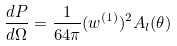<formula> <loc_0><loc_0><loc_500><loc_500>\frac { d P } { d \Omega } = \frac { 1 } { 6 4 \pi } ( w ^ { ( 1 ) } ) ^ { 2 } A _ { l } ( \theta )</formula> 